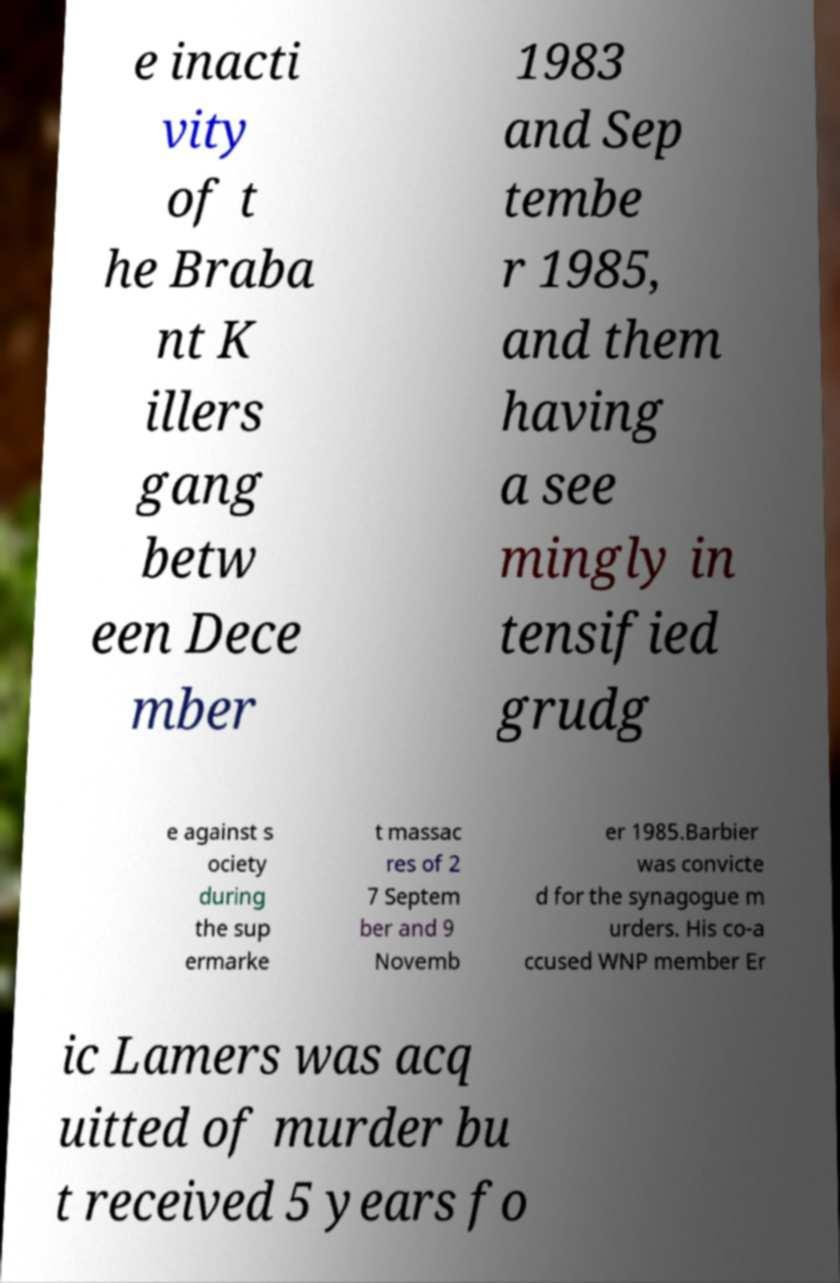Could you assist in decoding the text presented in this image and type it out clearly? e inacti vity of t he Braba nt K illers gang betw een Dece mber 1983 and Sep tembe r 1985, and them having a see mingly in tensified grudg e against s ociety during the sup ermarke t massac res of 2 7 Septem ber and 9 Novemb er 1985.Barbier was convicte d for the synagogue m urders. His co-a ccused WNP member Er ic Lamers was acq uitted of murder bu t received 5 years fo 